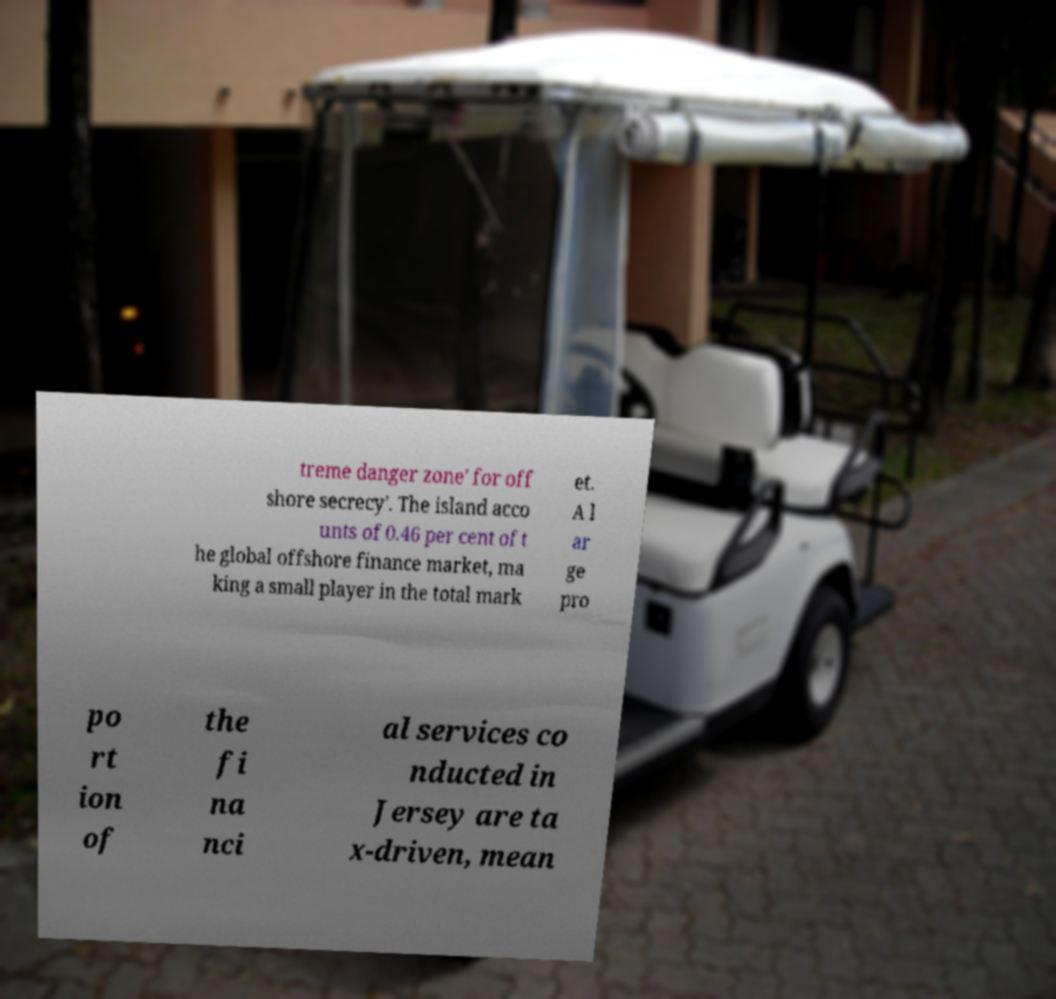Can you accurately transcribe the text from the provided image for me? treme danger zone' for off shore secrecy'. The island acco unts of 0.46 per cent of t he global offshore finance market, ma king a small player in the total mark et. A l ar ge pro po rt ion of the fi na nci al services co nducted in Jersey are ta x-driven, mean 